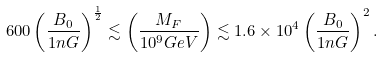<formula> <loc_0><loc_0><loc_500><loc_500>6 0 0 \left ( \frac { B _ { 0 } } { 1 n G } \right ) ^ { \frac { 1 } { 2 } } \lesssim \left ( \frac { M _ { F } } { 1 0 ^ { 9 } G e V } \right ) \lesssim 1 . 6 \times 1 0 ^ { 4 } \left ( \frac { B _ { 0 } } { 1 n G } \right ) ^ { 2 } .</formula> 